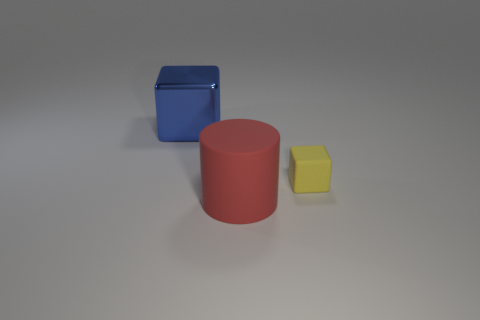Is there anything else that has the same size as the yellow matte object?
Keep it short and to the point. No. How many objects are blocks that are in front of the blue block or small objects?
Provide a short and direct response. 1. What number of other things are there of the same color as the big matte cylinder?
Give a very brief answer. 0. Do the tiny rubber object and the large object in front of the large block have the same color?
Provide a succinct answer. No. What is the color of the other small matte thing that is the same shape as the blue thing?
Ensure brevity in your answer.  Yellow. Are the small block and the big thing right of the metal cube made of the same material?
Ensure brevity in your answer.  Yes. What color is the large cylinder?
Ensure brevity in your answer.  Red. What color is the big object that is behind the large thing to the right of the cube that is behind the tiny object?
Offer a very short reply. Blue. Does the yellow rubber object have the same shape as the big object that is behind the rubber cylinder?
Offer a terse response. Yes. What is the color of the thing that is to the left of the yellow matte cube and behind the matte cylinder?
Offer a terse response. Blue. 